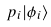Convert formula to latex. <formula><loc_0><loc_0><loc_500><loc_500>p _ { i } | \phi _ { i } \rangle</formula> 